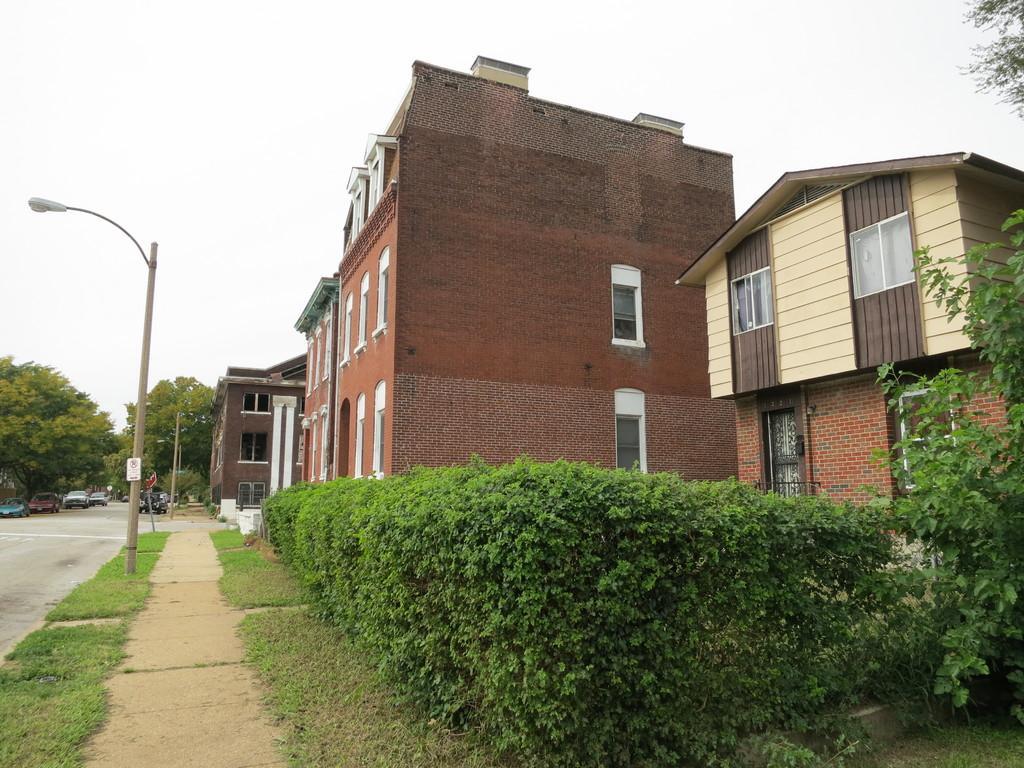Could you give a brief overview of what you see in this image? In this image I see number of buildings, bushes, path, green grass and I see a light pole over here. In the background I see number of trees, cars and I see the clear sky. 